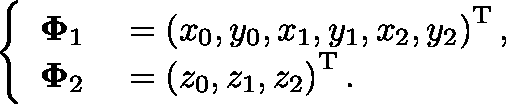Convert formula to latex. <formula><loc_0><loc_0><loc_500><loc_500>\left \{ \begin{array} { r l } { \Phi _ { 1 } } & = \left ( x _ { 0 } , y _ { 0 } , x _ { 1 } , y _ { 1 } , x _ { 2 } , y _ { 2 } \right ) ^ { T } , } \\ { \Phi _ { 2 } } & = \left ( z _ { 0 } , z _ { 1 } , z _ { 2 } \right ) ^ { T } . } \end{array}</formula> 